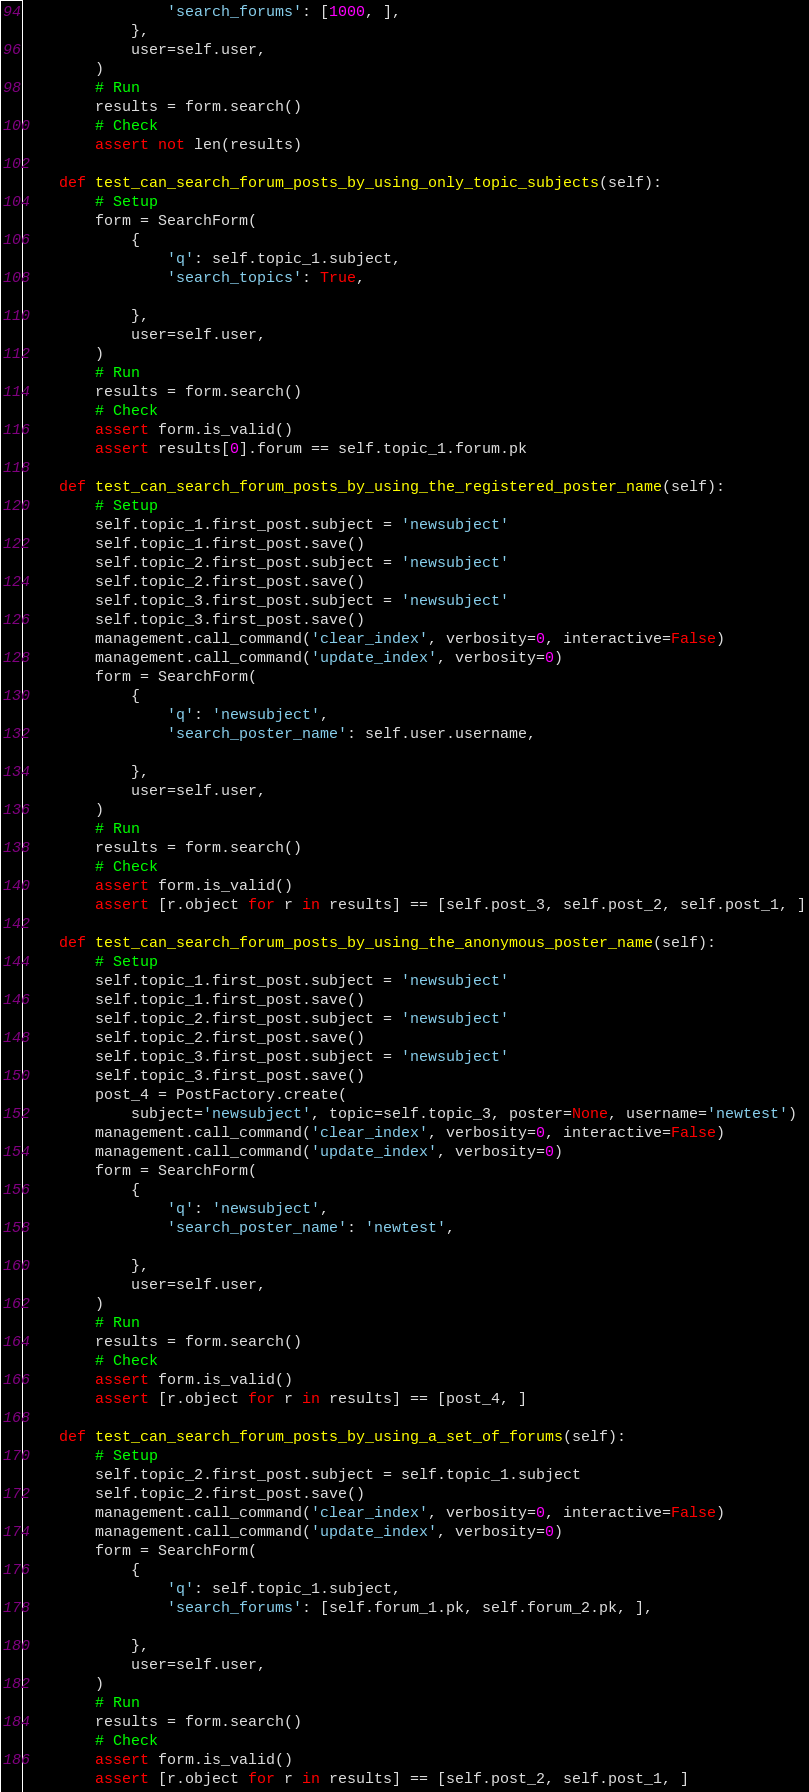<code> <loc_0><loc_0><loc_500><loc_500><_Python_>                'search_forums': [1000, ],
            },
            user=self.user,
        )
        # Run
        results = form.search()
        # Check
        assert not len(results)

    def test_can_search_forum_posts_by_using_only_topic_subjects(self):
        # Setup
        form = SearchForm(
            {
                'q': self.topic_1.subject,
                'search_topics': True,

            },
            user=self.user,
        )
        # Run
        results = form.search()
        # Check
        assert form.is_valid()
        assert results[0].forum == self.topic_1.forum.pk

    def test_can_search_forum_posts_by_using_the_registered_poster_name(self):
        # Setup
        self.topic_1.first_post.subject = 'newsubject'
        self.topic_1.first_post.save()
        self.topic_2.first_post.subject = 'newsubject'
        self.topic_2.first_post.save()
        self.topic_3.first_post.subject = 'newsubject'
        self.topic_3.first_post.save()
        management.call_command('clear_index', verbosity=0, interactive=False)
        management.call_command('update_index', verbosity=0)
        form = SearchForm(
            {
                'q': 'newsubject',
                'search_poster_name': self.user.username,

            },
            user=self.user,
        )
        # Run
        results = form.search()
        # Check
        assert form.is_valid()
        assert [r.object for r in results] == [self.post_3, self.post_2, self.post_1, ]

    def test_can_search_forum_posts_by_using_the_anonymous_poster_name(self):
        # Setup
        self.topic_1.first_post.subject = 'newsubject'
        self.topic_1.first_post.save()
        self.topic_2.first_post.subject = 'newsubject'
        self.topic_2.first_post.save()
        self.topic_3.first_post.subject = 'newsubject'
        self.topic_3.first_post.save()
        post_4 = PostFactory.create(
            subject='newsubject', topic=self.topic_3, poster=None, username='newtest')
        management.call_command('clear_index', verbosity=0, interactive=False)
        management.call_command('update_index', verbosity=0)
        form = SearchForm(
            {
                'q': 'newsubject',
                'search_poster_name': 'newtest',

            },
            user=self.user,
        )
        # Run
        results = form.search()
        # Check
        assert form.is_valid()
        assert [r.object for r in results] == [post_4, ]

    def test_can_search_forum_posts_by_using_a_set_of_forums(self):
        # Setup
        self.topic_2.first_post.subject = self.topic_1.subject
        self.topic_2.first_post.save()
        management.call_command('clear_index', verbosity=0, interactive=False)
        management.call_command('update_index', verbosity=0)
        form = SearchForm(
            {
                'q': self.topic_1.subject,
                'search_forums': [self.forum_1.pk, self.forum_2.pk, ],

            },
            user=self.user,
        )
        # Run
        results = form.search()
        # Check
        assert form.is_valid()
        assert [r.object for r in results] == [self.post_2, self.post_1, ]
</code> 